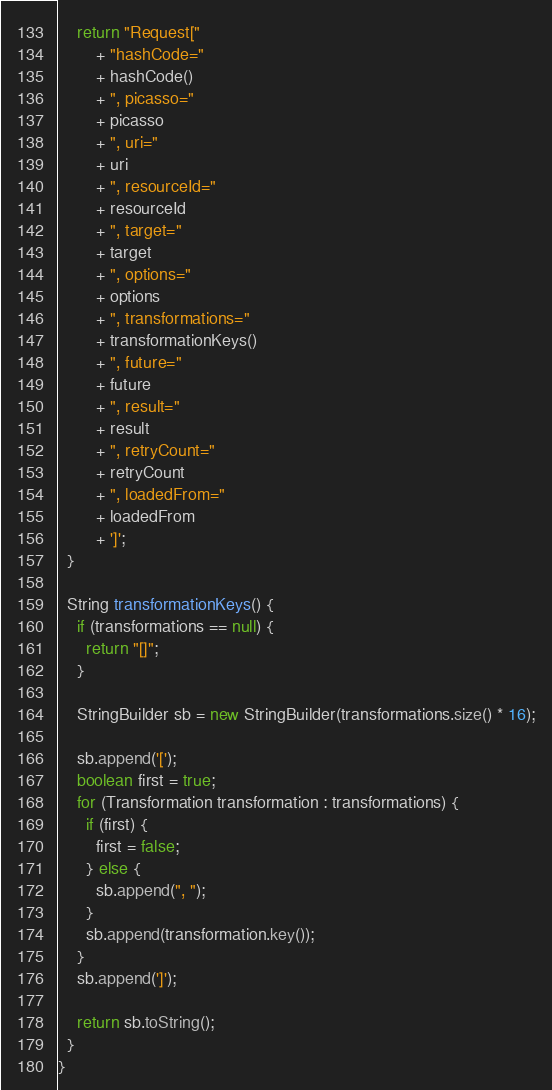Convert code to text. <code><loc_0><loc_0><loc_500><loc_500><_Java_>    return "Request["
        + "hashCode="
        + hashCode()
        + ", picasso="
        + picasso
        + ", uri="
        + uri
        + ", resourceId="
        + resourceId
        + ", target="
        + target
        + ", options="
        + options
        + ", transformations="
        + transformationKeys()
        + ", future="
        + future
        + ", result="
        + result
        + ", retryCount="
        + retryCount
        + ", loadedFrom="
        + loadedFrom
        + ']';
  }

  String transformationKeys() {
    if (transformations == null) {
      return "[]";
    }

    StringBuilder sb = new StringBuilder(transformations.size() * 16);

    sb.append('[');
    boolean first = true;
    for (Transformation transformation : transformations) {
      if (first) {
        first = false;
      } else {
        sb.append(", ");
      }
      sb.append(transformation.key());
    }
    sb.append(']');

    return sb.toString();
  }
}
</code> 